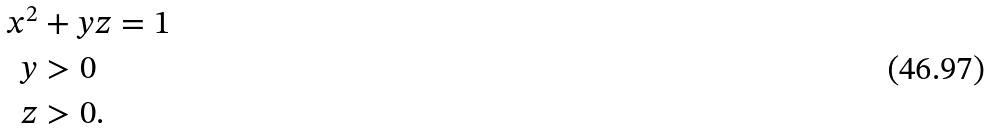<formula> <loc_0><loc_0><loc_500><loc_500>x ^ { 2 } & + y z = 1 \\ y & > 0 \\ z & > 0 .</formula> 